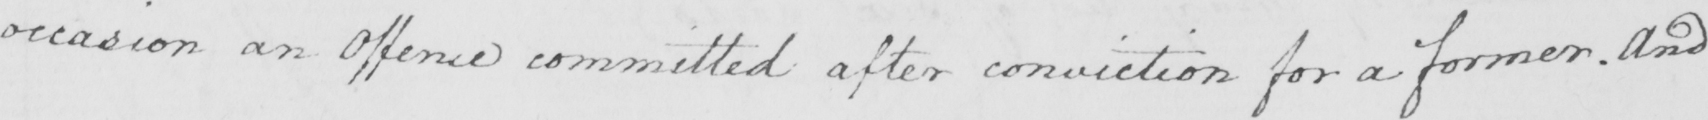Please transcribe the handwritten text in this image. occasion an Offence committed after conviction for a former . And 